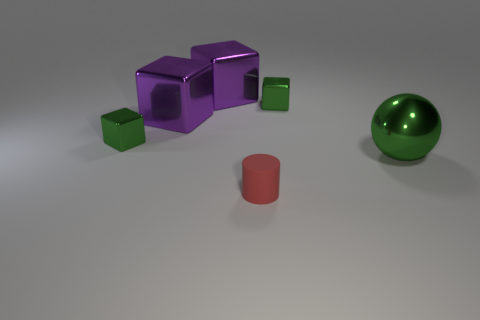There is a metal cube that is to the right of the tiny red rubber cylinder; is it the same size as the object in front of the green ball?
Make the answer very short. Yes. How many other things are there of the same size as the red matte thing?
Offer a terse response. 2. What number of things are either small shiny objects that are right of the tiny red object or small metallic blocks to the right of the cylinder?
Make the answer very short. 1. Do the red thing and the green block to the left of the tiny rubber object have the same material?
Your answer should be compact. No. What number of other objects are the same shape as the large green metal object?
Offer a terse response. 0. There is a big purple object that is behind the small block behind the small green object that is to the left of the tiny matte cylinder; what is its material?
Provide a succinct answer. Metal. Are there an equal number of matte things that are behind the red matte object and green spheres?
Your answer should be very brief. No. Is the green object on the left side of the tiny cylinder made of the same material as the small block that is on the right side of the tiny red object?
Your answer should be compact. Yes. Is there anything else that has the same material as the red cylinder?
Offer a terse response. No. There is a small object in front of the green metallic ball; is it the same shape as the small green object that is to the right of the red object?
Your answer should be compact. No. 